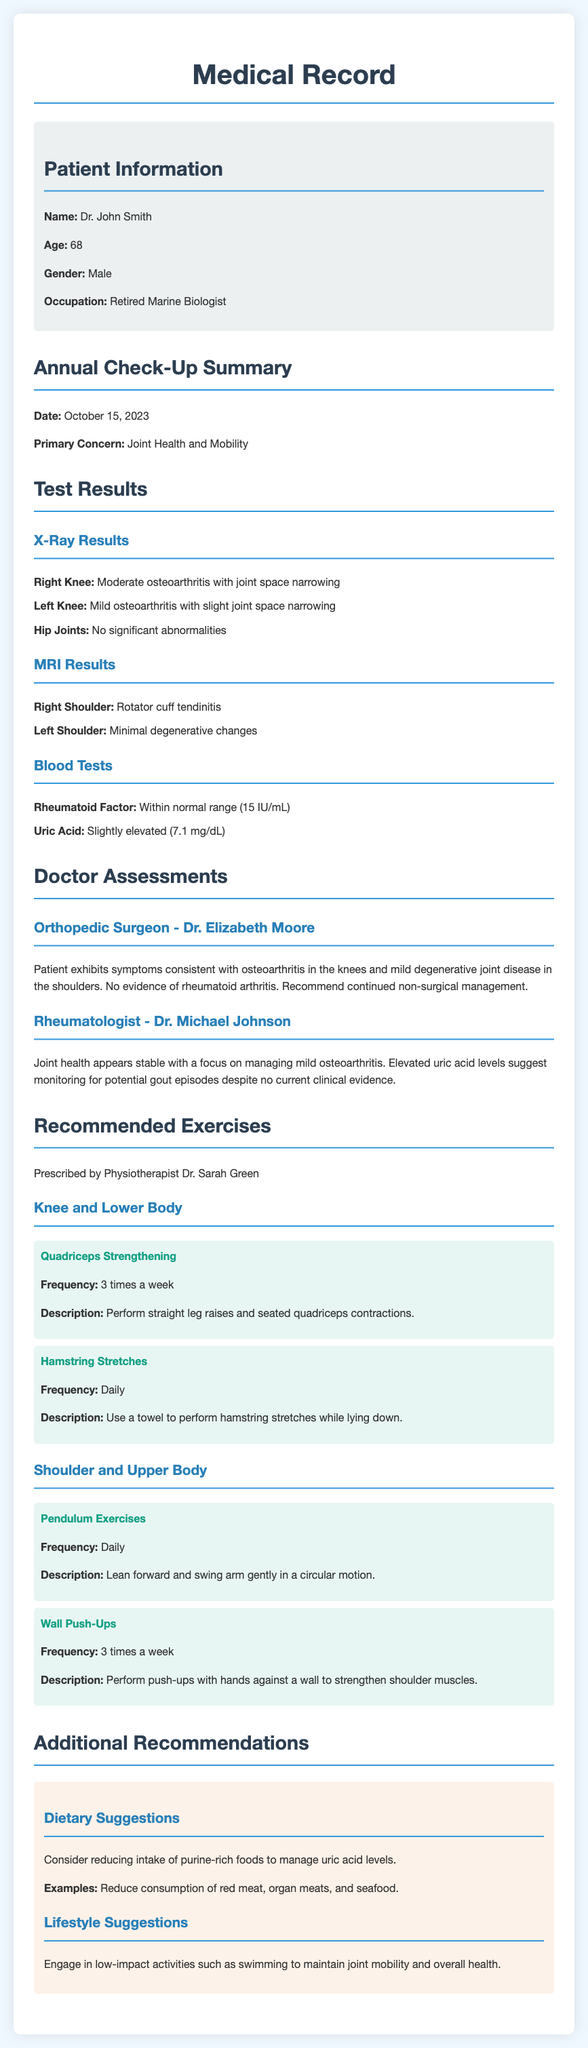What is the date of the annual check-up? The date mentioned in the document for the annual check-up is October 15, 2023.
Answer: October 15, 2023 What primary concern is focused on in this check-up? The primary concern addressed in the check-up is joint health and mobility.
Answer: Joint health and mobility Who is the orthopedic surgeon mentioned in the assessments? The orthopedic surgeon who assessed the patient is Dr. Elizabeth Moore.
Answer: Dr. Elizabeth Moore What is the condition of the right knee as per the X-ray results? The X-ray results indicate that the right knee has moderate osteoarthritis with joint space narrowing.
Answer: Moderate osteoarthritis with joint space narrowing What exercise is recommended for shoulder strengthening? The recommended exercise for shoulder strengthening is wall push-ups.
Answer: Wall push-ups How often should hamstring stretches be performed? It is recommended to perform hamstring stretches daily.
Answer: Daily What dietary suggestion is made to manage uric acid levels? One dietary suggestion is to reduce intake of purine-rich foods.
Answer: Reduce intake of purine-rich foods What is the patient's age? The patient's age as stated in the document is 68.
Answer: 68 Is there any evidence of rheumatoid arthritis in the assessments? No, the assessments indicate there is no evidence of rheumatoid arthritis.
Answer: No 